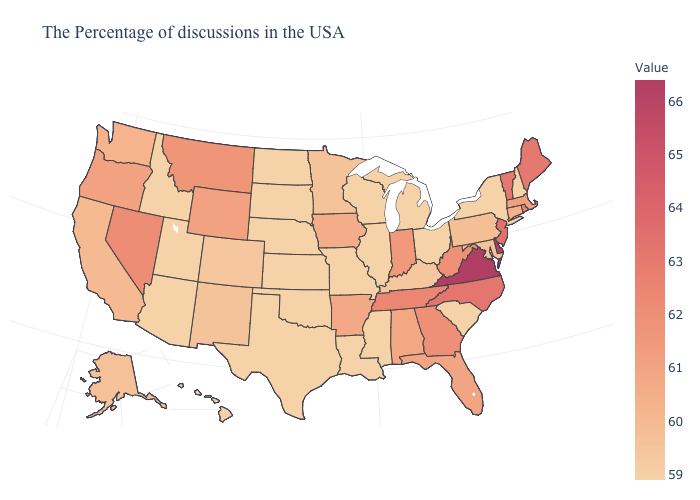Does Oregon have the highest value in the West?
Quick response, please. No. Among the states that border Washington , which have the lowest value?
Keep it brief. Idaho. Does Virginia have the highest value in the USA?
Keep it brief. Yes. Which states hav the highest value in the Northeast?
Be succinct. New Jersey. Among the states that border Pennsylvania , does New York have the lowest value?
Be succinct. Yes. Does Illinois have the highest value in the USA?
Quick response, please. No. Does West Virginia have a higher value than Delaware?
Be succinct. No. 